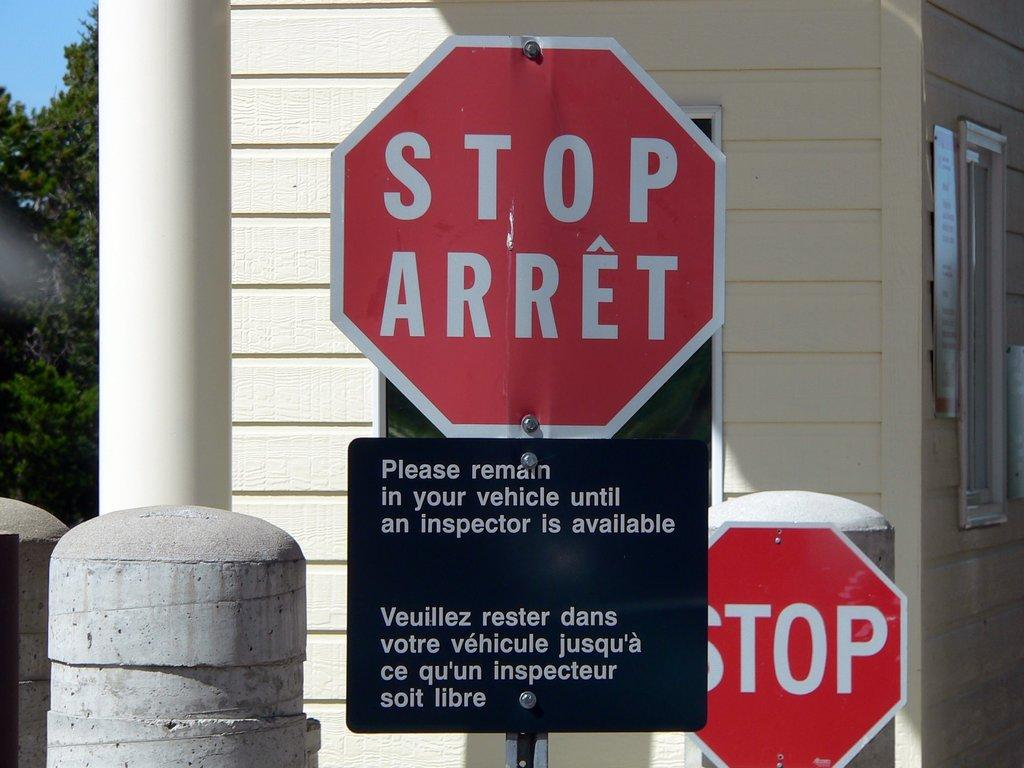<image>
Offer a succinct explanation of the picture presented. A white and red sign with the text STOP ARRET printed in white. 